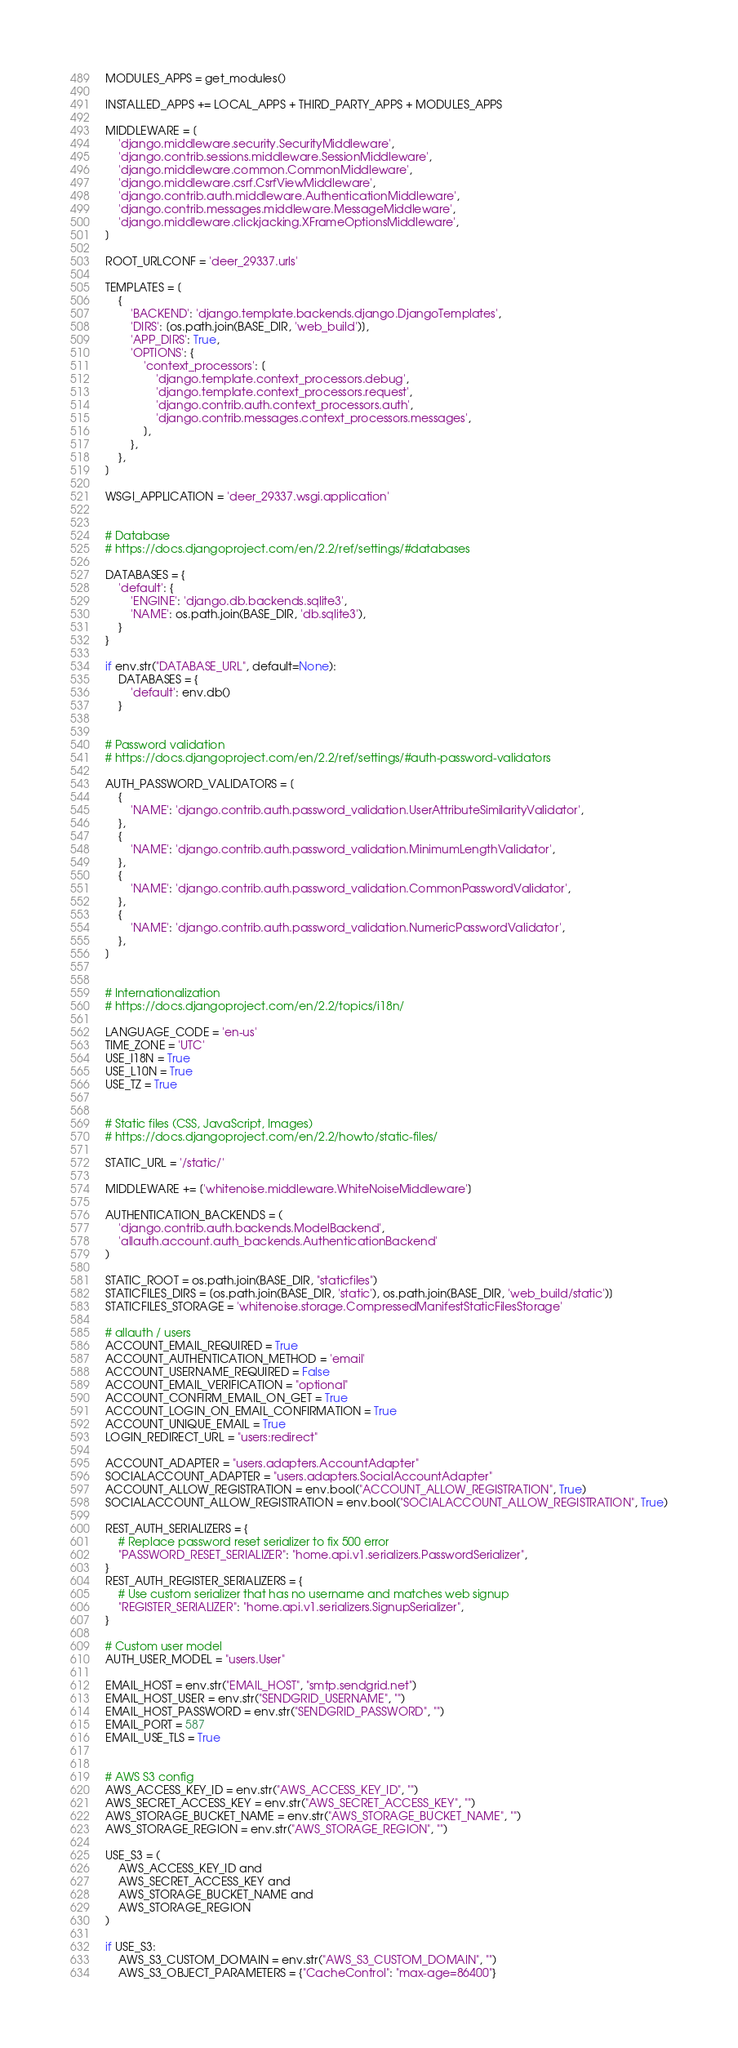<code> <loc_0><loc_0><loc_500><loc_500><_Python_>MODULES_APPS = get_modules()

INSTALLED_APPS += LOCAL_APPS + THIRD_PARTY_APPS + MODULES_APPS

MIDDLEWARE = [
    'django.middleware.security.SecurityMiddleware',
    'django.contrib.sessions.middleware.SessionMiddleware',
    'django.middleware.common.CommonMiddleware',
    'django.middleware.csrf.CsrfViewMiddleware',
    'django.contrib.auth.middleware.AuthenticationMiddleware',
    'django.contrib.messages.middleware.MessageMiddleware',
    'django.middleware.clickjacking.XFrameOptionsMiddleware',
]

ROOT_URLCONF = 'deer_29337.urls'

TEMPLATES = [
    {
        'BACKEND': 'django.template.backends.django.DjangoTemplates',
        'DIRS': [os.path.join(BASE_DIR, 'web_build')],
        'APP_DIRS': True,
        'OPTIONS': {
            'context_processors': [
                'django.template.context_processors.debug',
                'django.template.context_processors.request',
                'django.contrib.auth.context_processors.auth',
                'django.contrib.messages.context_processors.messages',
            ],
        },
    },
]

WSGI_APPLICATION = 'deer_29337.wsgi.application'


# Database
# https://docs.djangoproject.com/en/2.2/ref/settings/#databases

DATABASES = {
    'default': {
        'ENGINE': 'django.db.backends.sqlite3',
        'NAME': os.path.join(BASE_DIR, 'db.sqlite3'),
    }
}

if env.str("DATABASE_URL", default=None):
    DATABASES = {
        'default': env.db()
    }


# Password validation
# https://docs.djangoproject.com/en/2.2/ref/settings/#auth-password-validators

AUTH_PASSWORD_VALIDATORS = [
    {
        'NAME': 'django.contrib.auth.password_validation.UserAttributeSimilarityValidator',
    },
    {
        'NAME': 'django.contrib.auth.password_validation.MinimumLengthValidator',
    },
    {
        'NAME': 'django.contrib.auth.password_validation.CommonPasswordValidator',
    },
    {
        'NAME': 'django.contrib.auth.password_validation.NumericPasswordValidator',
    },
]


# Internationalization
# https://docs.djangoproject.com/en/2.2/topics/i18n/

LANGUAGE_CODE = 'en-us'
TIME_ZONE = 'UTC'
USE_I18N = True
USE_L10N = True
USE_TZ = True


# Static files (CSS, JavaScript, Images)
# https://docs.djangoproject.com/en/2.2/howto/static-files/

STATIC_URL = '/static/'

MIDDLEWARE += ['whitenoise.middleware.WhiteNoiseMiddleware']

AUTHENTICATION_BACKENDS = (
    'django.contrib.auth.backends.ModelBackend',
    'allauth.account.auth_backends.AuthenticationBackend'
)

STATIC_ROOT = os.path.join(BASE_DIR, "staticfiles")
STATICFILES_DIRS = [os.path.join(BASE_DIR, 'static'), os.path.join(BASE_DIR, 'web_build/static')]
STATICFILES_STORAGE = 'whitenoise.storage.CompressedManifestStaticFilesStorage'

# allauth / users
ACCOUNT_EMAIL_REQUIRED = True
ACCOUNT_AUTHENTICATION_METHOD = 'email'
ACCOUNT_USERNAME_REQUIRED = False
ACCOUNT_EMAIL_VERIFICATION = "optional"
ACCOUNT_CONFIRM_EMAIL_ON_GET = True
ACCOUNT_LOGIN_ON_EMAIL_CONFIRMATION = True
ACCOUNT_UNIQUE_EMAIL = True
LOGIN_REDIRECT_URL = "users:redirect"

ACCOUNT_ADAPTER = "users.adapters.AccountAdapter"
SOCIALACCOUNT_ADAPTER = "users.adapters.SocialAccountAdapter"
ACCOUNT_ALLOW_REGISTRATION = env.bool("ACCOUNT_ALLOW_REGISTRATION", True)
SOCIALACCOUNT_ALLOW_REGISTRATION = env.bool("SOCIALACCOUNT_ALLOW_REGISTRATION", True)

REST_AUTH_SERIALIZERS = {
    # Replace password reset serializer to fix 500 error
    "PASSWORD_RESET_SERIALIZER": "home.api.v1.serializers.PasswordSerializer",
}
REST_AUTH_REGISTER_SERIALIZERS = {
    # Use custom serializer that has no username and matches web signup
    "REGISTER_SERIALIZER": "home.api.v1.serializers.SignupSerializer",
}

# Custom user model
AUTH_USER_MODEL = "users.User"

EMAIL_HOST = env.str("EMAIL_HOST", "smtp.sendgrid.net")
EMAIL_HOST_USER = env.str("SENDGRID_USERNAME", "")
EMAIL_HOST_PASSWORD = env.str("SENDGRID_PASSWORD", "")
EMAIL_PORT = 587
EMAIL_USE_TLS = True


# AWS S3 config
AWS_ACCESS_KEY_ID = env.str("AWS_ACCESS_KEY_ID", "")
AWS_SECRET_ACCESS_KEY = env.str("AWS_SECRET_ACCESS_KEY", "")
AWS_STORAGE_BUCKET_NAME = env.str("AWS_STORAGE_BUCKET_NAME", "")
AWS_STORAGE_REGION = env.str("AWS_STORAGE_REGION", "")

USE_S3 = (
    AWS_ACCESS_KEY_ID and
    AWS_SECRET_ACCESS_KEY and
    AWS_STORAGE_BUCKET_NAME and
    AWS_STORAGE_REGION
)

if USE_S3:
    AWS_S3_CUSTOM_DOMAIN = env.str("AWS_S3_CUSTOM_DOMAIN", "")
    AWS_S3_OBJECT_PARAMETERS = {"CacheControl": "max-age=86400"}</code> 